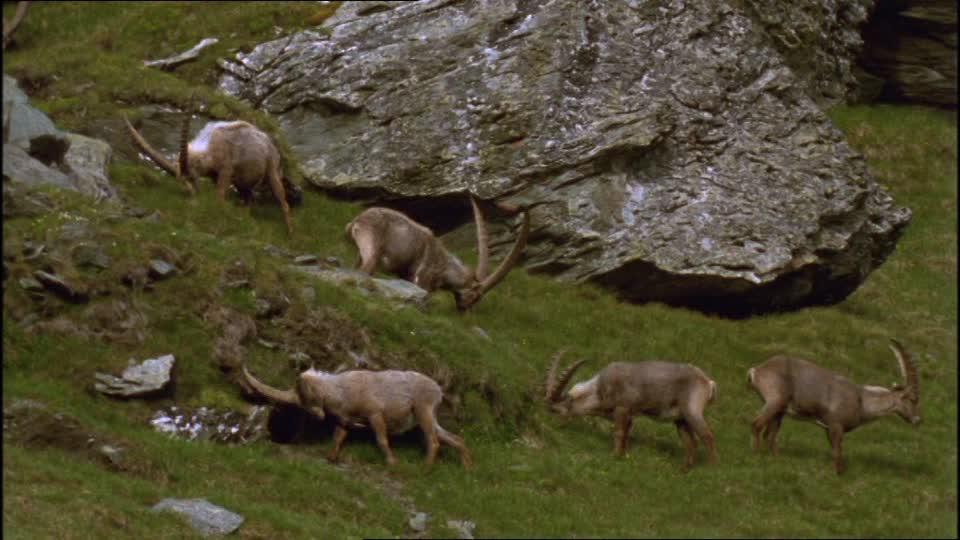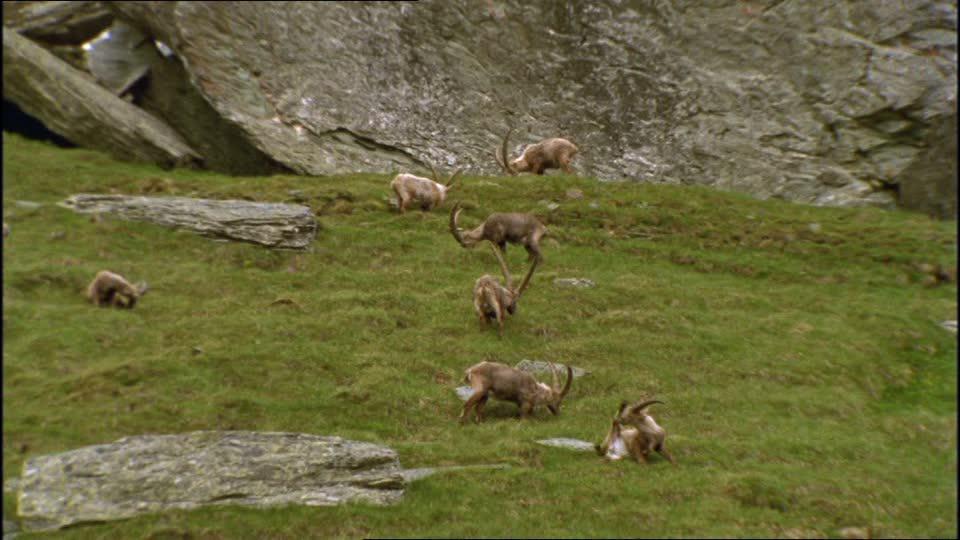The first image is the image on the left, the second image is the image on the right. For the images shown, is this caption "Right image shows multiple horned animals grazing, with lowered heads." true? Answer yes or no. Yes. The first image is the image on the left, the second image is the image on the right. Assess this claim about the two images: "There are no rocks near some of the animals.". Correct or not? Answer yes or no. No. 